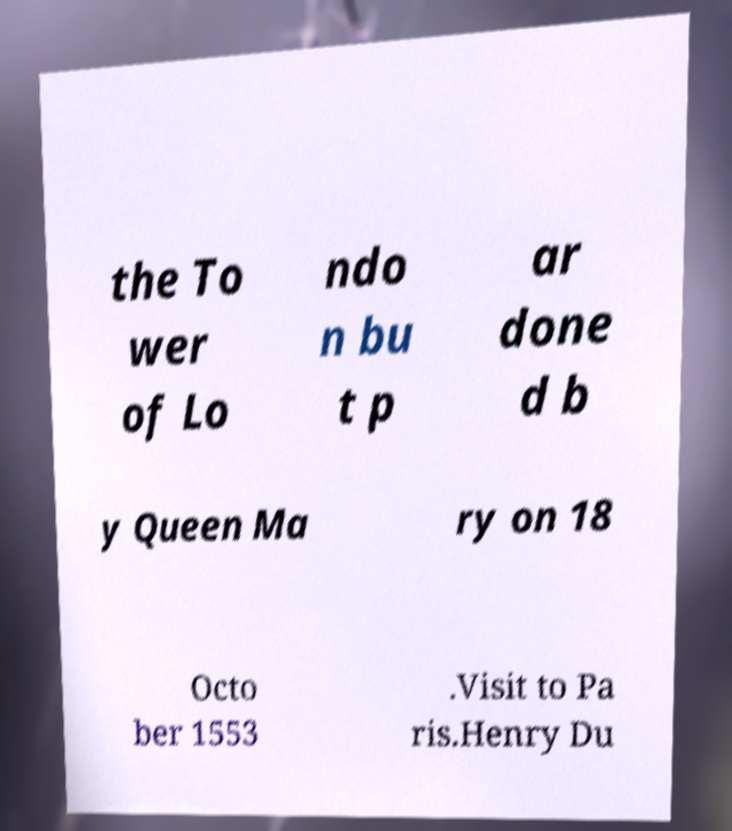Please identify and transcribe the text found in this image. the To wer of Lo ndo n bu t p ar done d b y Queen Ma ry on 18 Octo ber 1553 .Visit to Pa ris.Henry Du 